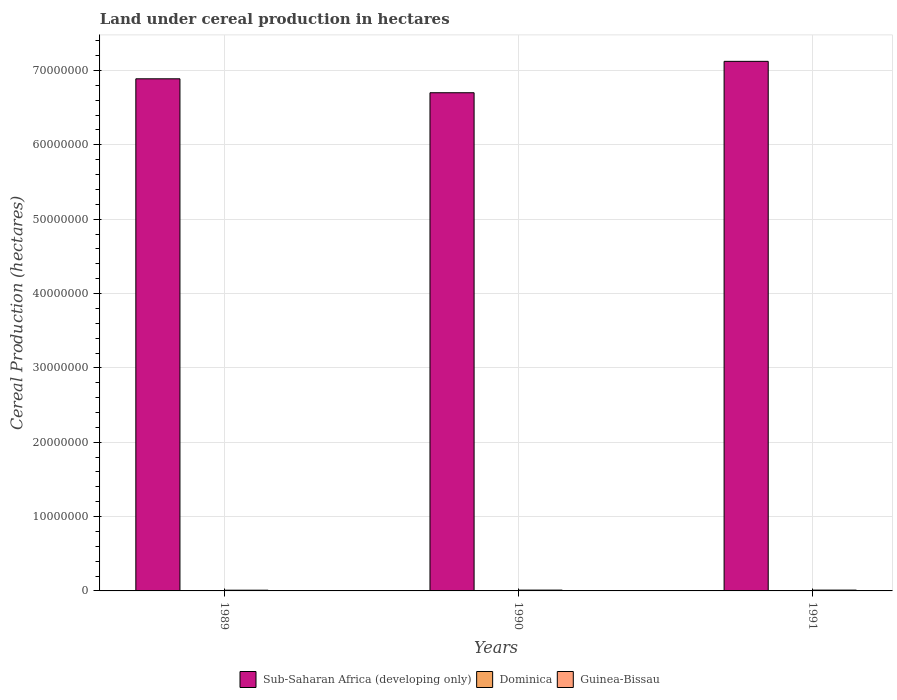How many groups of bars are there?
Keep it short and to the point. 3. Are the number of bars per tick equal to the number of legend labels?
Keep it short and to the point. Yes. What is the land under cereal production in Sub-Saharan Africa (developing only) in 1990?
Keep it short and to the point. 6.70e+07. Across all years, what is the maximum land under cereal production in Sub-Saharan Africa (developing only)?
Your answer should be very brief. 7.12e+07. Across all years, what is the minimum land under cereal production in Guinea-Bissau?
Your answer should be compact. 9.73e+04. In which year was the land under cereal production in Guinea-Bissau minimum?
Ensure brevity in your answer.  1989. What is the total land under cereal production in Dominica in the graph?
Make the answer very short. 337. What is the difference between the land under cereal production in Dominica in 1989 and that in 1990?
Give a very brief answer. 10. What is the difference between the land under cereal production in Guinea-Bissau in 1991 and the land under cereal production in Sub-Saharan Africa (developing only) in 1990?
Make the answer very short. -6.69e+07. What is the average land under cereal production in Dominica per year?
Your answer should be compact. 112.33. In the year 1989, what is the difference between the land under cereal production in Sub-Saharan Africa (developing only) and land under cereal production in Dominica?
Give a very brief answer. 6.89e+07. In how many years, is the land under cereal production in Sub-Saharan Africa (developing only) greater than 16000000 hectares?
Your answer should be compact. 3. What is the ratio of the land under cereal production in Sub-Saharan Africa (developing only) in 1990 to that in 1991?
Offer a terse response. 0.94. What is the difference between the highest and the second highest land under cereal production in Sub-Saharan Africa (developing only)?
Your answer should be very brief. 2.35e+06. What is the difference between the highest and the lowest land under cereal production in Dominica?
Your answer should be very brief. 13. What does the 3rd bar from the left in 1990 represents?
Provide a succinct answer. Guinea-Bissau. What does the 1st bar from the right in 1991 represents?
Ensure brevity in your answer.  Guinea-Bissau. How many years are there in the graph?
Your answer should be compact. 3. Are the values on the major ticks of Y-axis written in scientific E-notation?
Give a very brief answer. No. Does the graph contain any zero values?
Ensure brevity in your answer.  No. Where does the legend appear in the graph?
Ensure brevity in your answer.  Bottom center. What is the title of the graph?
Offer a terse response. Land under cereal production in hectares. Does "Bhutan" appear as one of the legend labels in the graph?
Make the answer very short. No. What is the label or title of the Y-axis?
Keep it short and to the point. Cereal Production (hectares). What is the Cereal Production (hectares) in Sub-Saharan Africa (developing only) in 1989?
Give a very brief answer. 6.89e+07. What is the Cereal Production (hectares) of Dominica in 1989?
Your answer should be very brief. 120. What is the Cereal Production (hectares) of Guinea-Bissau in 1989?
Provide a short and direct response. 9.73e+04. What is the Cereal Production (hectares) in Sub-Saharan Africa (developing only) in 1990?
Your response must be concise. 6.70e+07. What is the Cereal Production (hectares) in Dominica in 1990?
Your answer should be compact. 110. What is the Cereal Production (hectares) of Guinea-Bissau in 1990?
Make the answer very short. 1.09e+05. What is the Cereal Production (hectares) of Sub-Saharan Africa (developing only) in 1991?
Offer a very short reply. 7.12e+07. What is the Cereal Production (hectares) in Dominica in 1991?
Offer a terse response. 107. What is the Cereal Production (hectares) of Guinea-Bissau in 1991?
Offer a terse response. 1.11e+05. Across all years, what is the maximum Cereal Production (hectares) in Sub-Saharan Africa (developing only)?
Keep it short and to the point. 7.12e+07. Across all years, what is the maximum Cereal Production (hectares) of Dominica?
Your response must be concise. 120. Across all years, what is the maximum Cereal Production (hectares) of Guinea-Bissau?
Give a very brief answer. 1.11e+05. Across all years, what is the minimum Cereal Production (hectares) of Sub-Saharan Africa (developing only)?
Your answer should be compact. 6.70e+07. Across all years, what is the minimum Cereal Production (hectares) of Dominica?
Ensure brevity in your answer.  107. Across all years, what is the minimum Cereal Production (hectares) of Guinea-Bissau?
Provide a short and direct response. 9.73e+04. What is the total Cereal Production (hectares) in Sub-Saharan Africa (developing only) in the graph?
Make the answer very short. 2.07e+08. What is the total Cereal Production (hectares) in Dominica in the graph?
Your response must be concise. 337. What is the total Cereal Production (hectares) of Guinea-Bissau in the graph?
Provide a succinct answer. 3.17e+05. What is the difference between the Cereal Production (hectares) of Sub-Saharan Africa (developing only) in 1989 and that in 1990?
Ensure brevity in your answer.  1.87e+06. What is the difference between the Cereal Production (hectares) of Guinea-Bissau in 1989 and that in 1990?
Provide a short and direct response. -1.20e+04. What is the difference between the Cereal Production (hectares) of Sub-Saharan Africa (developing only) in 1989 and that in 1991?
Offer a terse response. -2.35e+06. What is the difference between the Cereal Production (hectares) of Guinea-Bissau in 1989 and that in 1991?
Make the answer very short. -1.35e+04. What is the difference between the Cereal Production (hectares) of Sub-Saharan Africa (developing only) in 1990 and that in 1991?
Make the answer very short. -4.22e+06. What is the difference between the Cereal Production (hectares) of Dominica in 1990 and that in 1991?
Keep it short and to the point. 3. What is the difference between the Cereal Production (hectares) of Guinea-Bissau in 1990 and that in 1991?
Your response must be concise. -1551. What is the difference between the Cereal Production (hectares) of Sub-Saharan Africa (developing only) in 1989 and the Cereal Production (hectares) of Dominica in 1990?
Give a very brief answer. 6.89e+07. What is the difference between the Cereal Production (hectares) of Sub-Saharan Africa (developing only) in 1989 and the Cereal Production (hectares) of Guinea-Bissau in 1990?
Give a very brief answer. 6.88e+07. What is the difference between the Cereal Production (hectares) in Dominica in 1989 and the Cereal Production (hectares) in Guinea-Bissau in 1990?
Give a very brief answer. -1.09e+05. What is the difference between the Cereal Production (hectares) of Sub-Saharan Africa (developing only) in 1989 and the Cereal Production (hectares) of Dominica in 1991?
Your answer should be very brief. 6.89e+07. What is the difference between the Cereal Production (hectares) of Sub-Saharan Africa (developing only) in 1989 and the Cereal Production (hectares) of Guinea-Bissau in 1991?
Your response must be concise. 6.88e+07. What is the difference between the Cereal Production (hectares) in Dominica in 1989 and the Cereal Production (hectares) in Guinea-Bissau in 1991?
Your answer should be compact. -1.11e+05. What is the difference between the Cereal Production (hectares) of Sub-Saharan Africa (developing only) in 1990 and the Cereal Production (hectares) of Dominica in 1991?
Keep it short and to the point. 6.70e+07. What is the difference between the Cereal Production (hectares) of Sub-Saharan Africa (developing only) in 1990 and the Cereal Production (hectares) of Guinea-Bissau in 1991?
Provide a short and direct response. 6.69e+07. What is the difference between the Cereal Production (hectares) of Dominica in 1990 and the Cereal Production (hectares) of Guinea-Bissau in 1991?
Ensure brevity in your answer.  -1.11e+05. What is the average Cereal Production (hectares) of Sub-Saharan Africa (developing only) per year?
Keep it short and to the point. 6.90e+07. What is the average Cereal Production (hectares) of Dominica per year?
Your answer should be very brief. 112.33. What is the average Cereal Production (hectares) in Guinea-Bissau per year?
Your answer should be compact. 1.06e+05. In the year 1989, what is the difference between the Cereal Production (hectares) in Sub-Saharan Africa (developing only) and Cereal Production (hectares) in Dominica?
Ensure brevity in your answer.  6.89e+07. In the year 1989, what is the difference between the Cereal Production (hectares) in Sub-Saharan Africa (developing only) and Cereal Production (hectares) in Guinea-Bissau?
Ensure brevity in your answer.  6.88e+07. In the year 1989, what is the difference between the Cereal Production (hectares) of Dominica and Cereal Production (hectares) of Guinea-Bissau?
Make the answer very short. -9.72e+04. In the year 1990, what is the difference between the Cereal Production (hectares) in Sub-Saharan Africa (developing only) and Cereal Production (hectares) in Dominica?
Keep it short and to the point. 6.70e+07. In the year 1990, what is the difference between the Cereal Production (hectares) in Sub-Saharan Africa (developing only) and Cereal Production (hectares) in Guinea-Bissau?
Make the answer very short. 6.69e+07. In the year 1990, what is the difference between the Cereal Production (hectares) in Dominica and Cereal Production (hectares) in Guinea-Bissau?
Offer a terse response. -1.09e+05. In the year 1991, what is the difference between the Cereal Production (hectares) in Sub-Saharan Africa (developing only) and Cereal Production (hectares) in Dominica?
Keep it short and to the point. 7.12e+07. In the year 1991, what is the difference between the Cereal Production (hectares) of Sub-Saharan Africa (developing only) and Cereal Production (hectares) of Guinea-Bissau?
Provide a short and direct response. 7.11e+07. In the year 1991, what is the difference between the Cereal Production (hectares) of Dominica and Cereal Production (hectares) of Guinea-Bissau?
Your answer should be compact. -1.11e+05. What is the ratio of the Cereal Production (hectares) in Sub-Saharan Africa (developing only) in 1989 to that in 1990?
Provide a succinct answer. 1.03. What is the ratio of the Cereal Production (hectares) of Guinea-Bissau in 1989 to that in 1990?
Your answer should be very brief. 0.89. What is the ratio of the Cereal Production (hectares) in Dominica in 1989 to that in 1991?
Give a very brief answer. 1.12. What is the ratio of the Cereal Production (hectares) in Guinea-Bissau in 1989 to that in 1991?
Keep it short and to the point. 0.88. What is the ratio of the Cereal Production (hectares) of Sub-Saharan Africa (developing only) in 1990 to that in 1991?
Your answer should be very brief. 0.94. What is the ratio of the Cereal Production (hectares) of Dominica in 1990 to that in 1991?
Provide a short and direct response. 1.03. What is the ratio of the Cereal Production (hectares) in Guinea-Bissau in 1990 to that in 1991?
Ensure brevity in your answer.  0.99. What is the difference between the highest and the second highest Cereal Production (hectares) of Sub-Saharan Africa (developing only)?
Your answer should be compact. 2.35e+06. What is the difference between the highest and the second highest Cereal Production (hectares) in Guinea-Bissau?
Provide a succinct answer. 1551. What is the difference between the highest and the lowest Cereal Production (hectares) in Sub-Saharan Africa (developing only)?
Give a very brief answer. 4.22e+06. What is the difference between the highest and the lowest Cereal Production (hectares) of Guinea-Bissau?
Provide a short and direct response. 1.35e+04. 